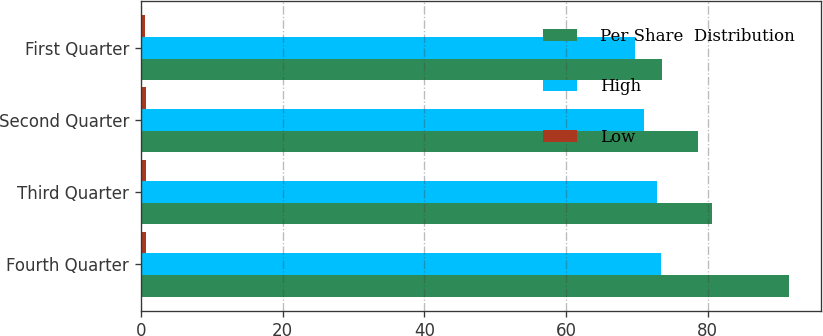<chart> <loc_0><loc_0><loc_500><loc_500><stacked_bar_chart><ecel><fcel>Fourth Quarter<fcel>Third Quarter<fcel>Second Quarter<fcel>First Quarter<nl><fcel>Per Share  Distribution<fcel>91.49<fcel>80.65<fcel>78.69<fcel>73.51<nl><fcel>High<fcel>73.44<fcel>72.91<fcel>70.97<fcel>69.77<nl><fcel>Low<fcel>0.74<fcel>0.72<fcel>0.72<fcel>0.6<nl></chart> 